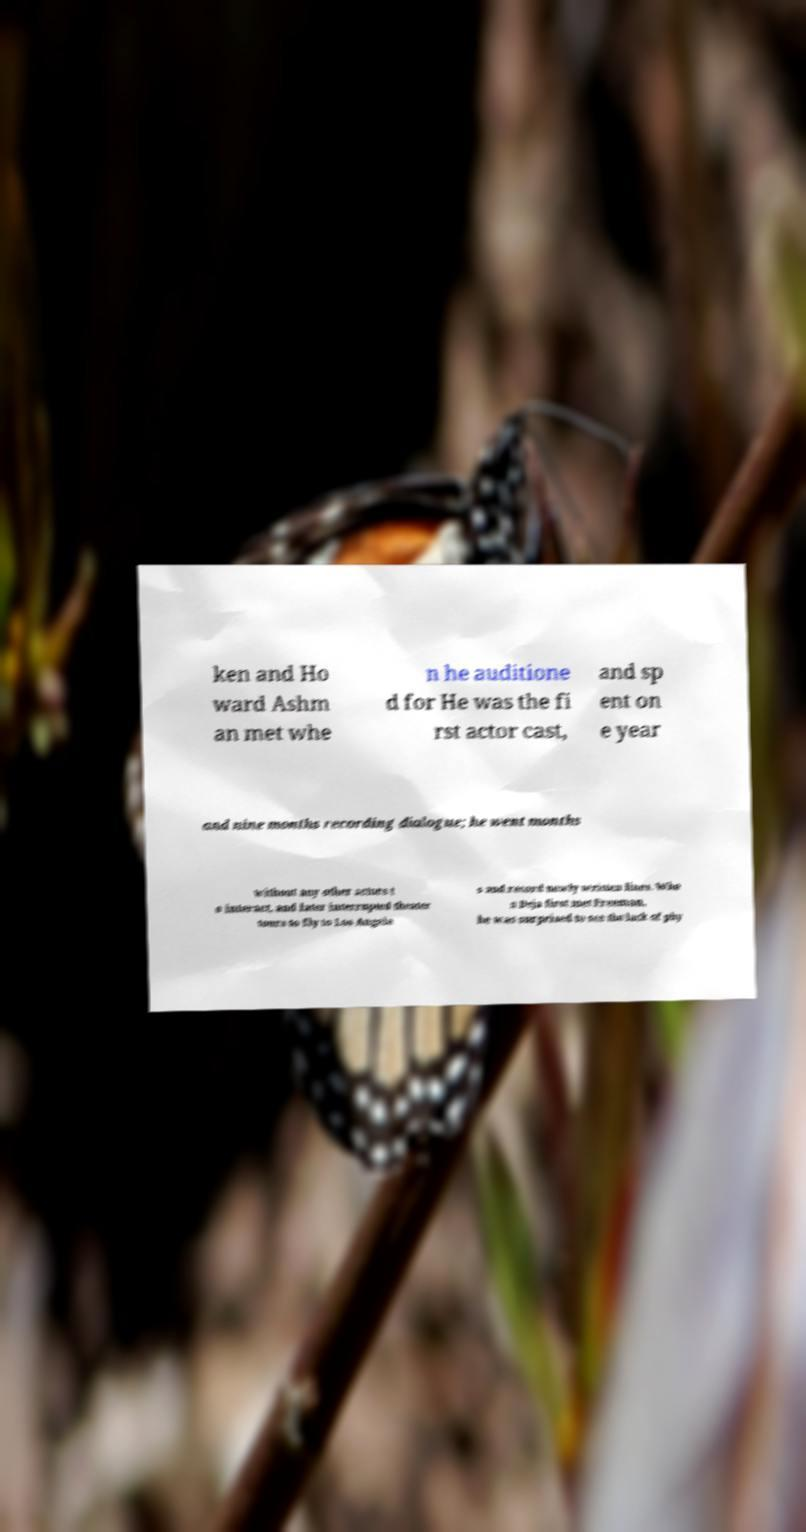I need the written content from this picture converted into text. Can you do that? ken and Ho ward Ashm an met whe n he auditione d for He was the fi rst actor cast, and sp ent on e year and nine months recording dialogue; he went months without any other actors t o interact, and later interrupted theater tours to fly to Los Angele s and record newly written lines. Whe n Deja first met Freeman, he was surprised to see the lack of phy 